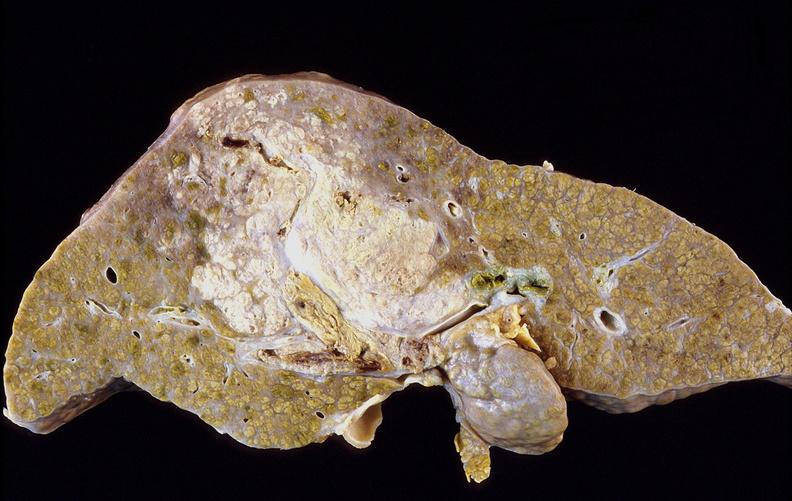does this image show hepatocellular carcinoma, hepatitis c positive?
Answer the question using a single word or phrase. Yes 